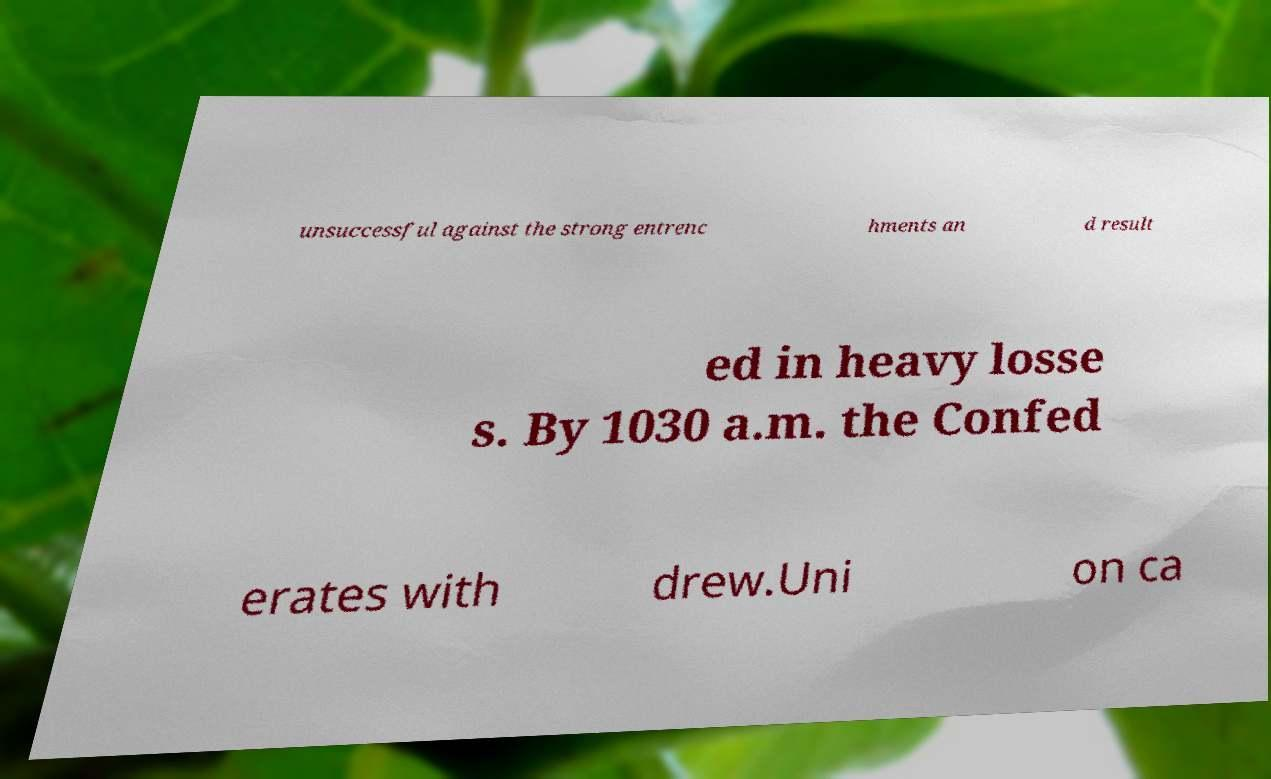Please identify and transcribe the text found in this image. unsuccessful against the strong entrenc hments an d result ed in heavy losse s. By 1030 a.m. the Confed erates with drew.Uni on ca 